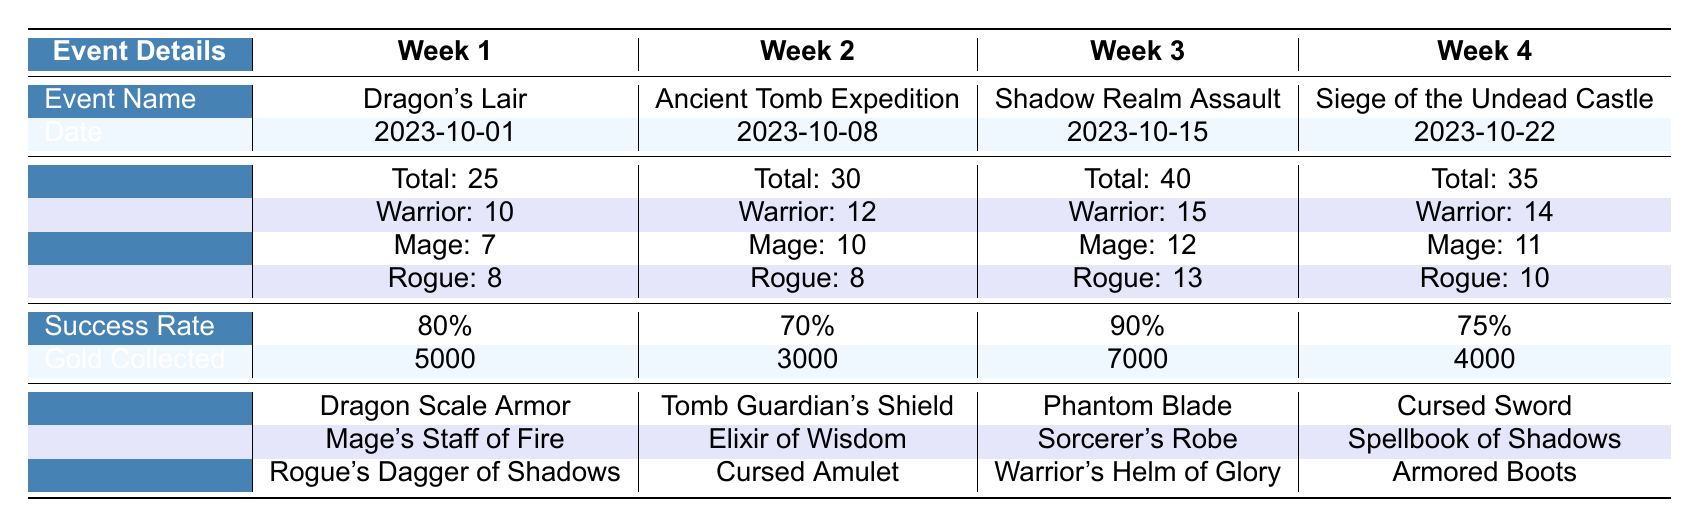What event had the highest number of participants? By looking at the table, the "Shadow Realm Assault" in Week 3 has the highest total number of participants, which is 40.
Answer: Shadow Realm Assault What was the success rate for the Siege of the Undead Castle? The success rate for the Siege of the Undead Castle in Week 4 is listed as 75%.
Answer: 75% How much gold was collected during the Dragon's Lair event? According to the table, the Dragon's Lair event in Week 1 resulted in collecting 5000 gold.
Answer: 5000 Which week had the least number of participants? Comparing the total participants across all weeks, Week 1 had the fewest participants with a total of 25.
Answer: Week 1 What is the average number of Warriors across all events? To find the average, add the number of Warriors from each event: (10 + 12 + 15 + 14) = 51. Then divide by 4 (the number of events): 51 / 4 = 12.75.
Answer: 12.75 Was the success rate for Week 2 lower than 80%? The success rate for Week 2 is 70%, which is indeed lower than 80%.
Answer: Yes How many different items were collected in total during all events? The items collected for each event are as follows: 3 from Week 1, 3 from Week 2, 3 from Week 3, and 3 from Week 4. Adding them gives: 3 + 3 + 3 + 3 = 12 items in total.
Answer: 12 Did the number of Rogues in Week 3 exceed the total number of Mages across all weeks? The number of Rogues in Week 3 is 13, while the total number of Mages across all weeks is (7 + 10 + 12 + 11) = 40. Since 13 does not exceed 40, the answer is no.
Answer: No What item was collected during the Ancient Tomb Expedition? In Week 2, the item collected during the Ancient Tomb Expedition was the Tomb Guardian's Shield.
Answer: Tomb Guardian's Shield 